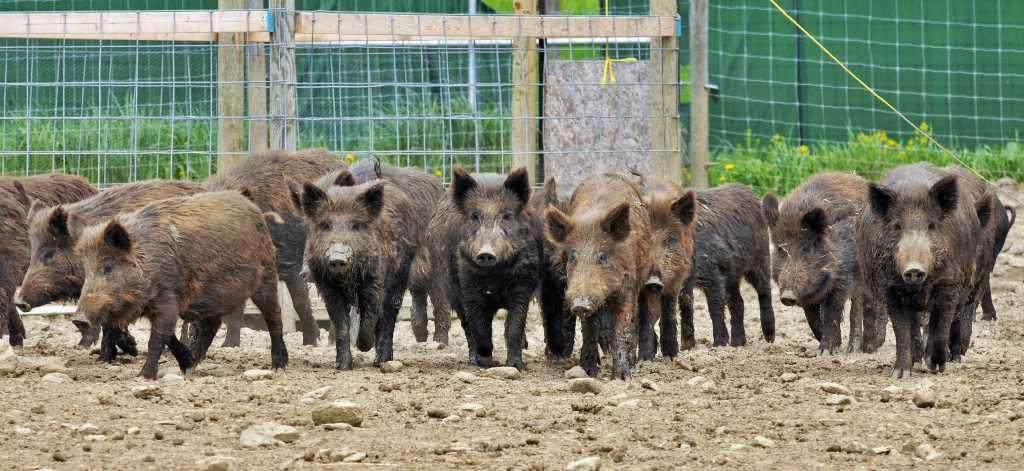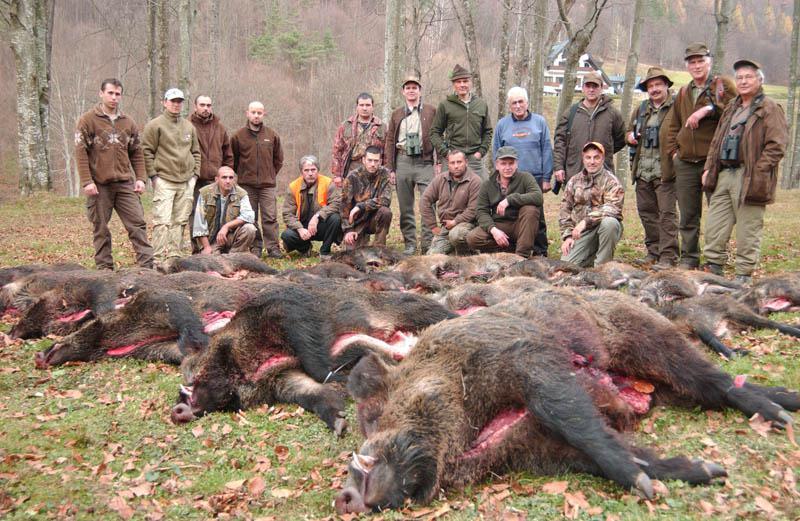The first image is the image on the left, the second image is the image on the right. For the images displayed, is the sentence "The right image contains exactly two pigs." factually correct? Answer yes or no. No. The first image is the image on the left, the second image is the image on the right. For the images shown, is this caption "An image includes at least one tusked boar lying on the ground, and at least one other kind of mammal in the picture." true? Answer yes or no. Yes. 